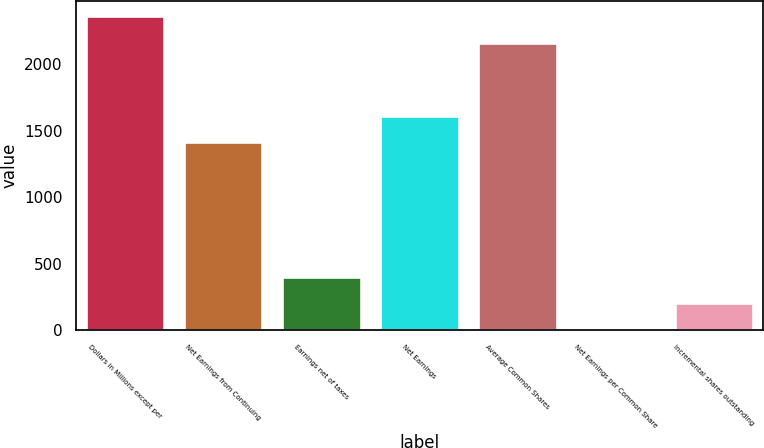Convert chart to OTSL. <chart><loc_0><loc_0><loc_500><loc_500><bar_chart><fcel>Dollars in Millions except per<fcel>Net Earnings from Continuing<fcel>Earnings net of taxes<fcel>Net Earnings<fcel>Average Common Shares<fcel>Net Earnings per Common Share<fcel>Incremental shares outstanding<nl><fcel>2361.04<fcel>1414.52<fcel>401.85<fcel>1615.04<fcel>2160.52<fcel>0.81<fcel>201.33<nl></chart> 